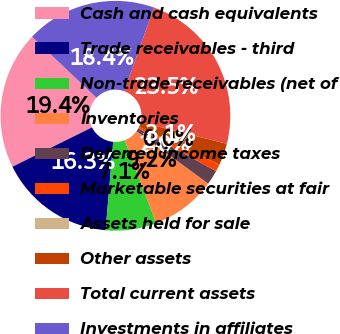Convert chart to OTSL. <chart><loc_0><loc_0><loc_500><loc_500><pie_chart><fcel>Cash and cash equivalents<fcel>Trade receivables - third<fcel>Non-trade receivables (net of<fcel>Inventories<fcel>Deferred income taxes<fcel>Marketable securities at fair<fcel>Assets held for sale<fcel>Other assets<fcel>Total current assets<fcel>Investments in affiliates<nl><fcel>19.39%<fcel>16.32%<fcel>7.14%<fcel>9.18%<fcel>2.04%<fcel>1.02%<fcel>0.0%<fcel>3.06%<fcel>23.47%<fcel>18.37%<nl></chart> 